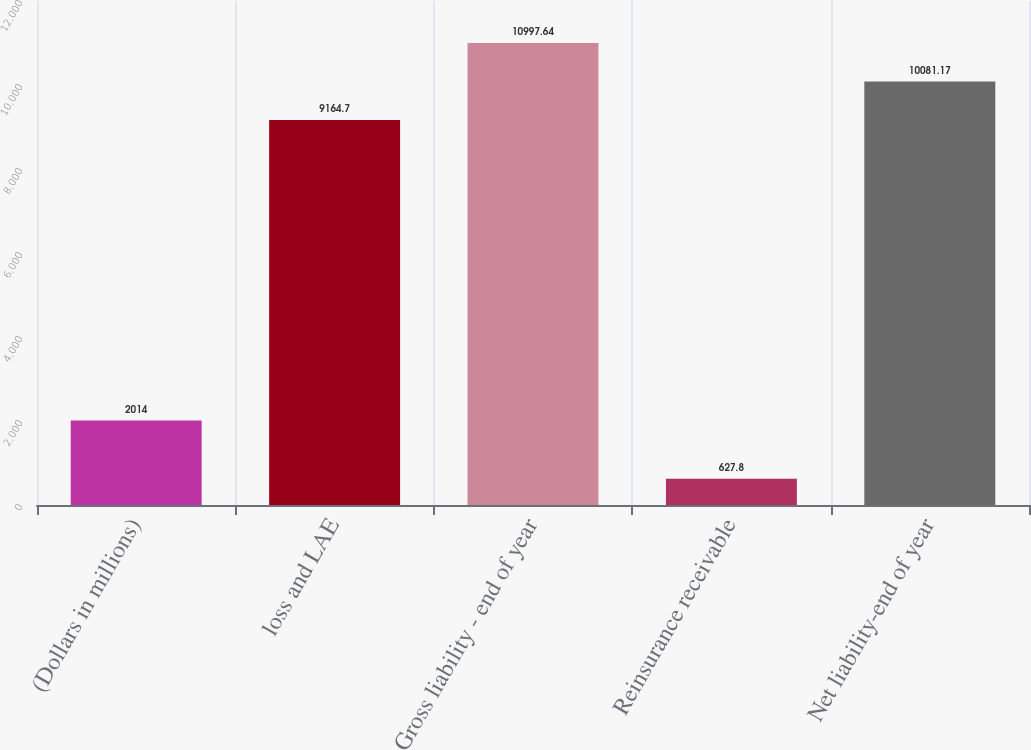Convert chart to OTSL. <chart><loc_0><loc_0><loc_500><loc_500><bar_chart><fcel>(Dollars in millions)<fcel>loss and LAE<fcel>Gross liability - end of year<fcel>Reinsurance receivable<fcel>Net liability-end of year<nl><fcel>2014<fcel>9164.7<fcel>10997.6<fcel>627.8<fcel>10081.2<nl></chart> 